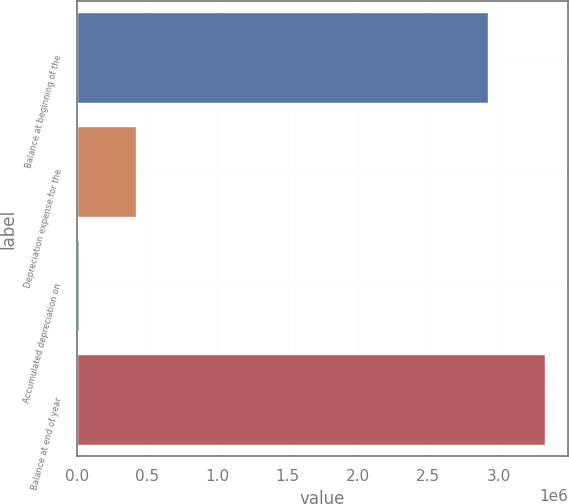Convert chart. <chart><loc_0><loc_0><loc_500><loc_500><bar_chart><fcel>Balance at beginning of the<fcel>Depreciation expense for the<fcel>Accumulated depreciation on<fcel>Balance at end of year<nl><fcel>2.92362e+06<fcel>424772<fcel>18231<fcel>3.33017e+06<nl></chart> 